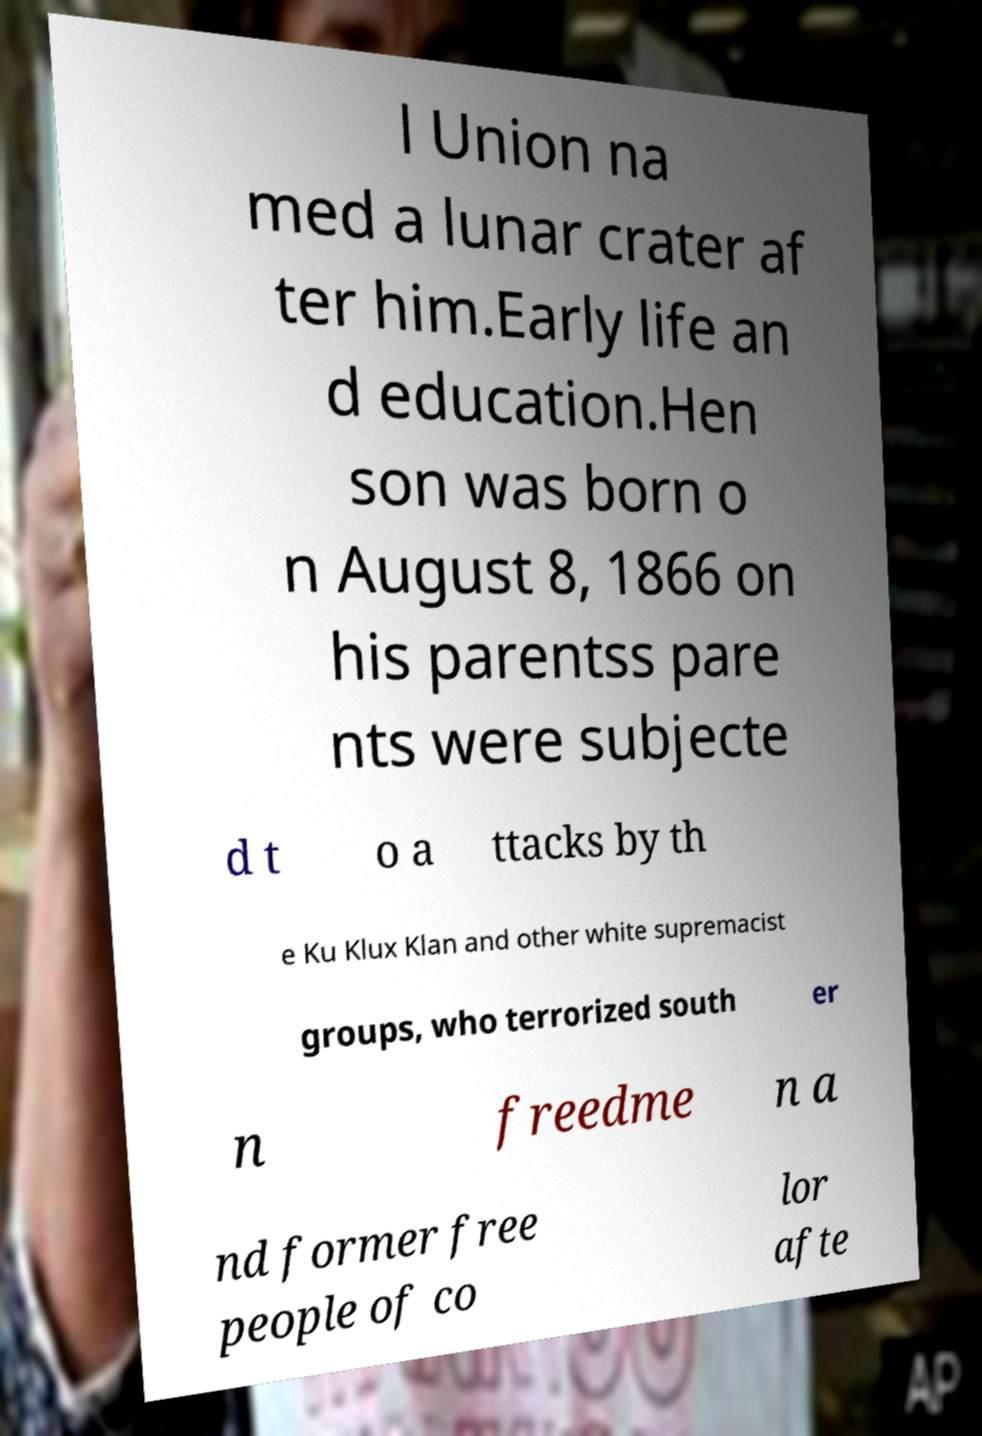Can you read and provide the text displayed in the image?This photo seems to have some interesting text. Can you extract and type it out for me? l Union na med a lunar crater af ter him.Early life an d education.Hen son was born o n August 8, 1866 on his parentss pare nts were subjecte d t o a ttacks by th e Ku Klux Klan and other white supremacist groups, who terrorized south er n freedme n a nd former free people of co lor afte 